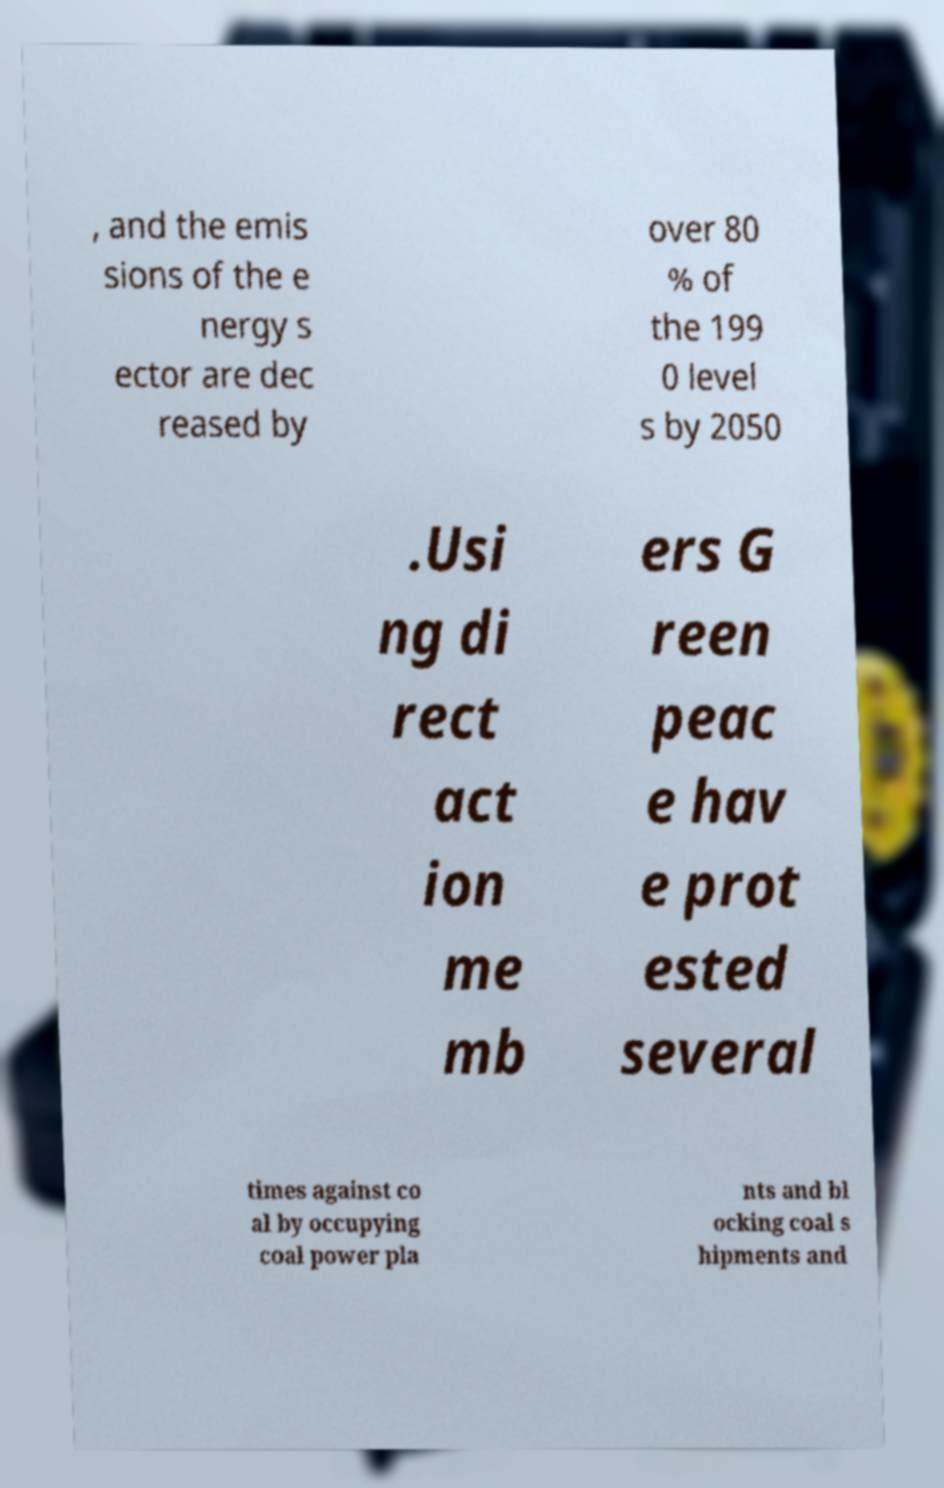Can you accurately transcribe the text from the provided image for me? , and the emis sions of the e nergy s ector are dec reased by over 80 % of the 199 0 level s by 2050 .Usi ng di rect act ion me mb ers G reen peac e hav e prot ested several times against co al by occupying coal power pla nts and bl ocking coal s hipments and 